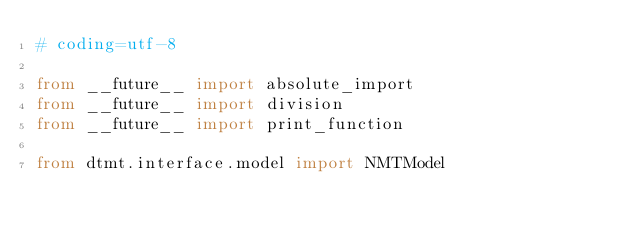Convert code to text. <code><loc_0><loc_0><loc_500><loc_500><_Python_># coding=utf-8

from __future__ import absolute_import
from __future__ import division
from __future__ import print_function

from dtmt.interface.model import NMTModel
</code> 